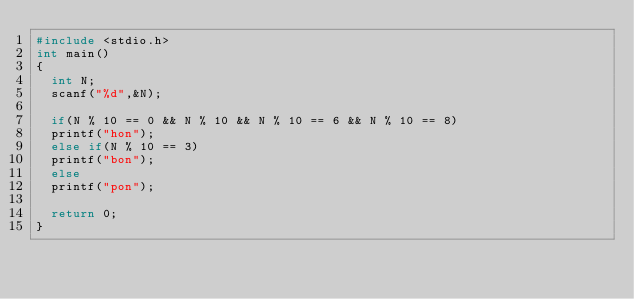Convert code to text. <code><loc_0><loc_0><loc_500><loc_500><_C_>#include <stdio.h>
int main()
{
  int N;
  scanf("%d",&N);

  if(N % 10 == 0 && N % 10 && N % 10 == 6 && N % 10 == 8)
  printf("hon");
  else if(N % 10 == 3)
  printf("bon");
  else
  printf("pon");

  return 0;
}
</code> 